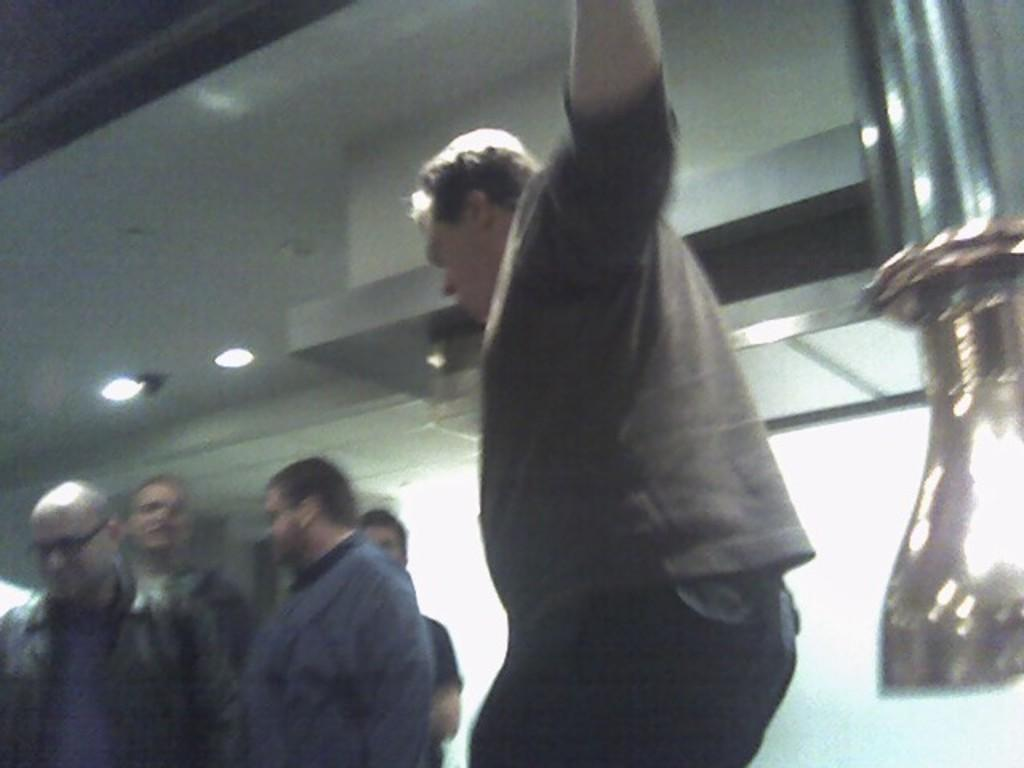What are the people in the image doing? The people in the image are standing in the center. What object can be seen on the right side of the image? There is a vase on the right side of the image. What can be seen in the background of the image? There is a light and a wall in the background of the image. Who is the owner of the business in the image? There is no business or owner mentioned or visible in the image. 